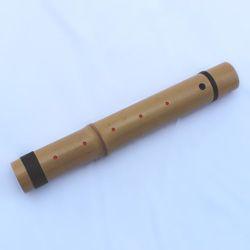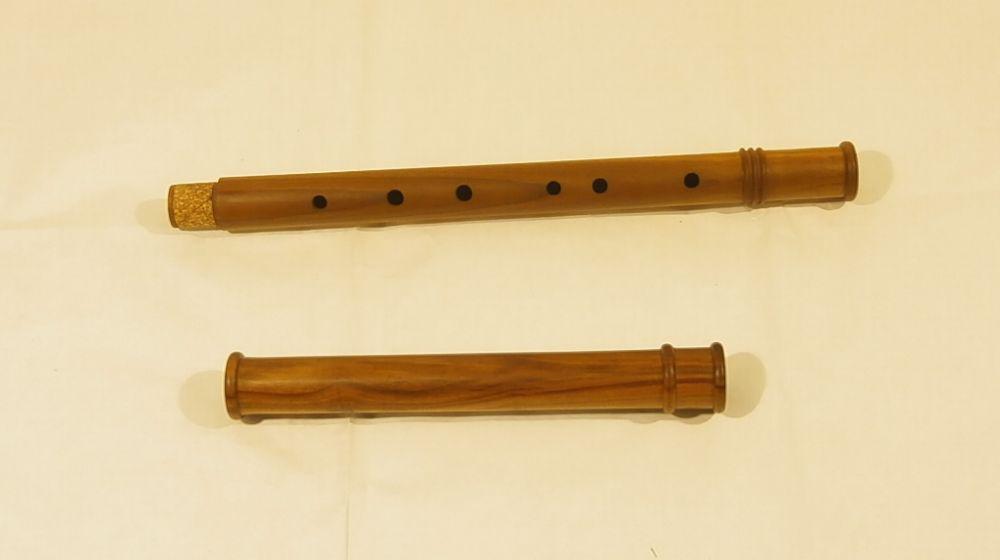The first image is the image on the left, the second image is the image on the right. For the images displayed, is the sentence "In at least one image there is a brown wooden flute with only 7 drilled holes in it." factually correct? Answer yes or no. No. The first image is the image on the left, the second image is the image on the right. Assess this claim about the two images: "Each image contains only one flute, which is displayed somewhat horizontally.". Correct or not? Answer yes or no. No. 